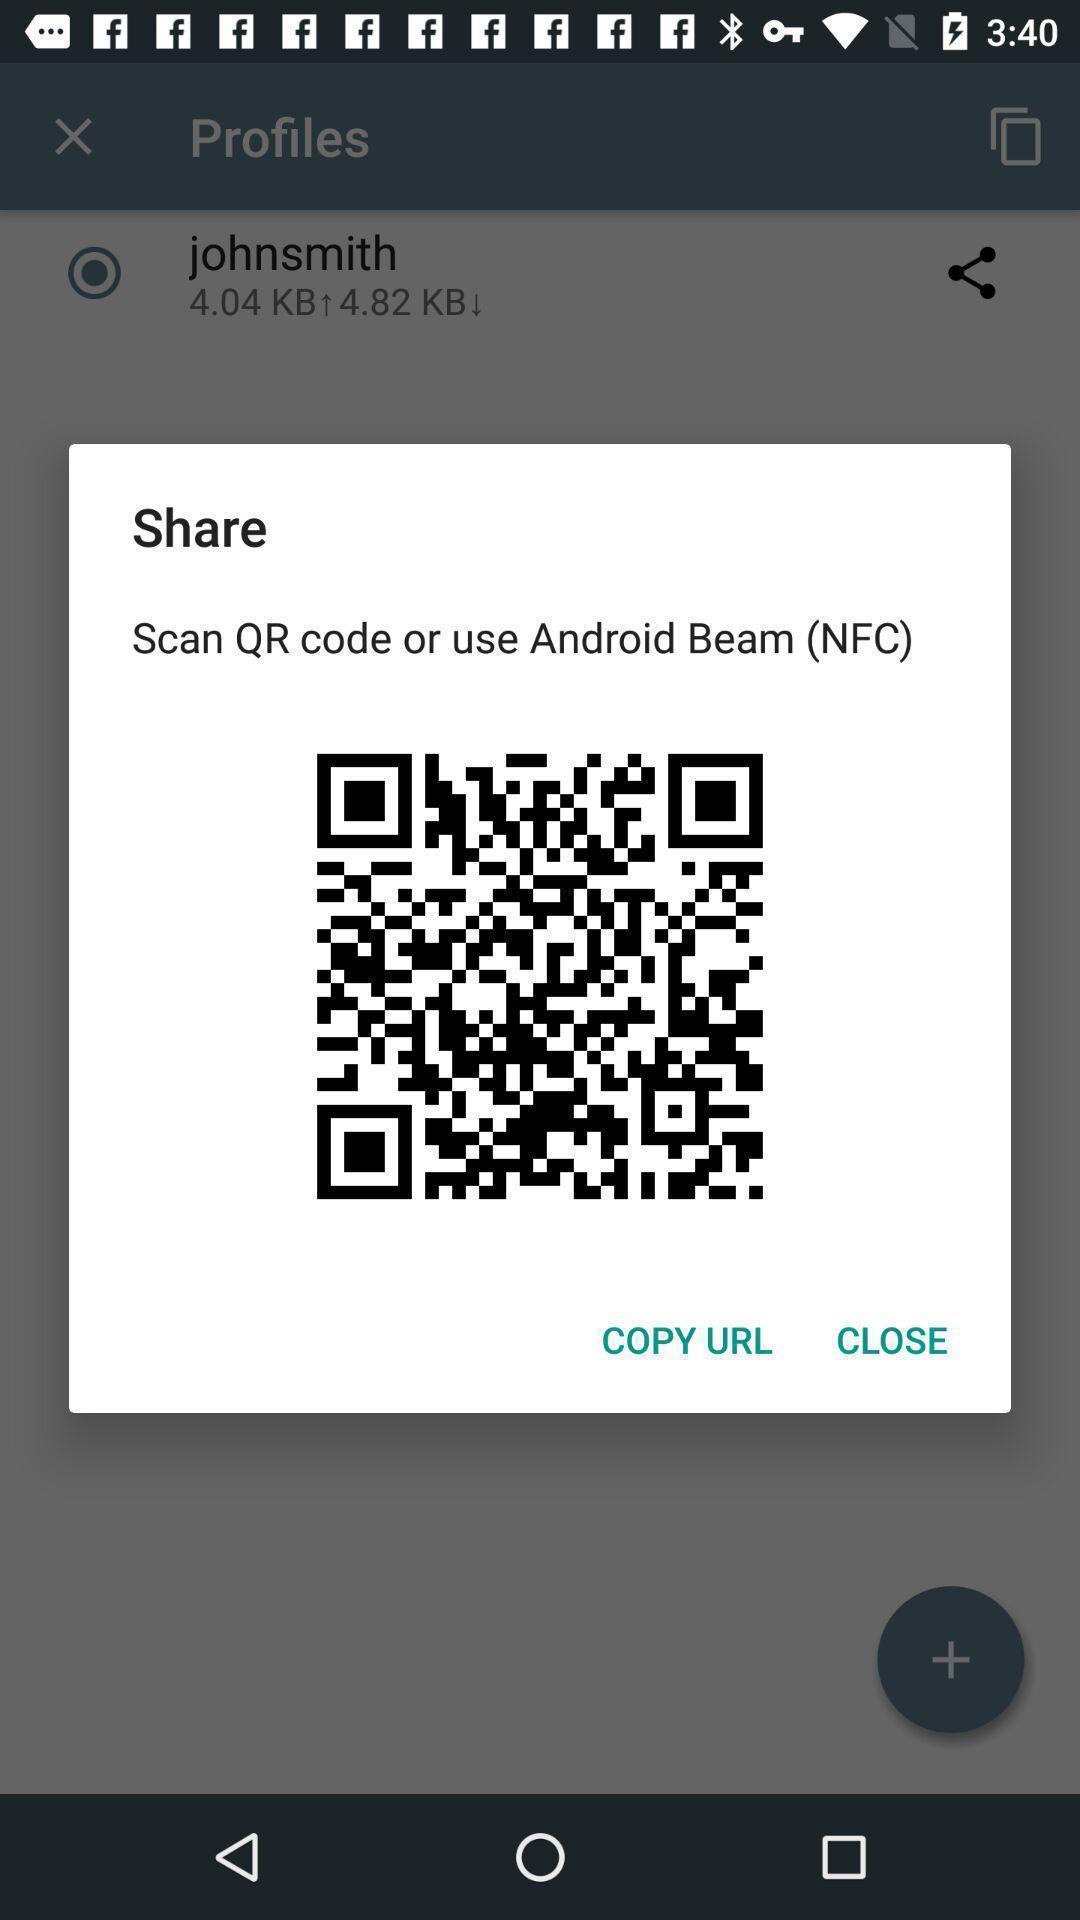Explain what's happening in this screen capture. Popup of qr code for digital transactions. 